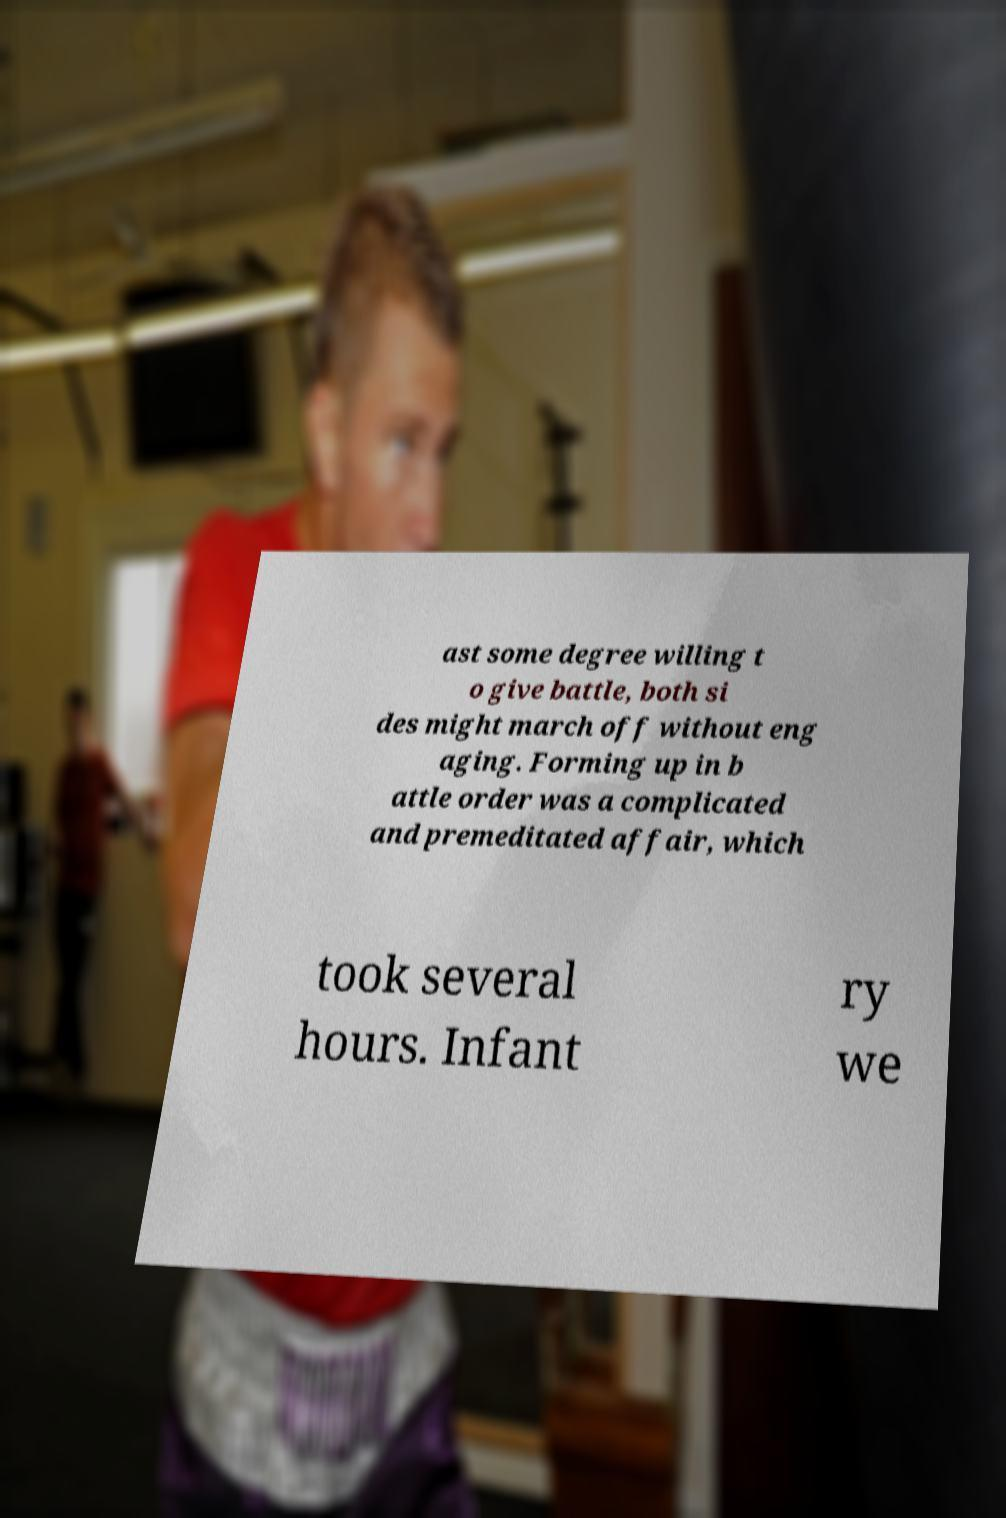What messages or text are displayed in this image? I need them in a readable, typed format. ast some degree willing t o give battle, both si des might march off without eng aging. Forming up in b attle order was a complicated and premeditated affair, which took several hours. Infant ry we 